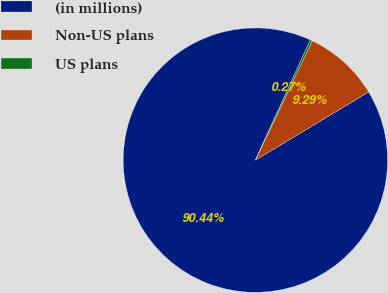Convert chart to OTSL. <chart><loc_0><loc_0><loc_500><loc_500><pie_chart><fcel>(in millions)<fcel>Non-US plans<fcel>US plans<nl><fcel>90.44%<fcel>9.29%<fcel>0.27%<nl></chart> 